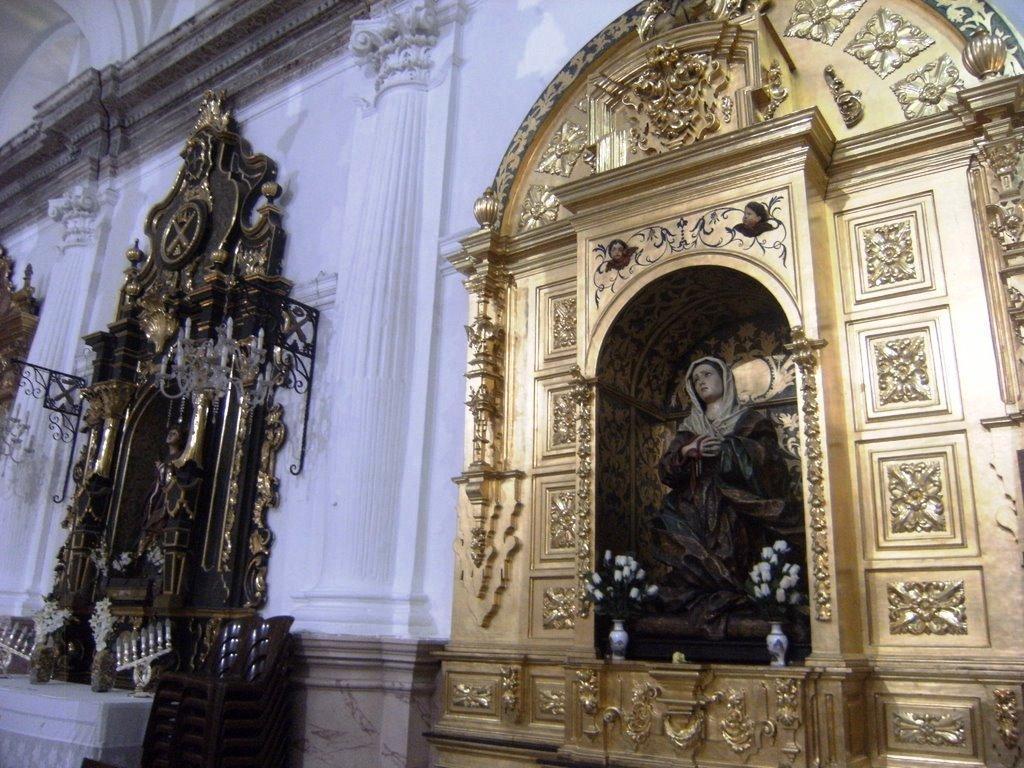Could you give a brief overview of what you see in this image? In this image there are sculptures and some other structures on the wall with pillars. 